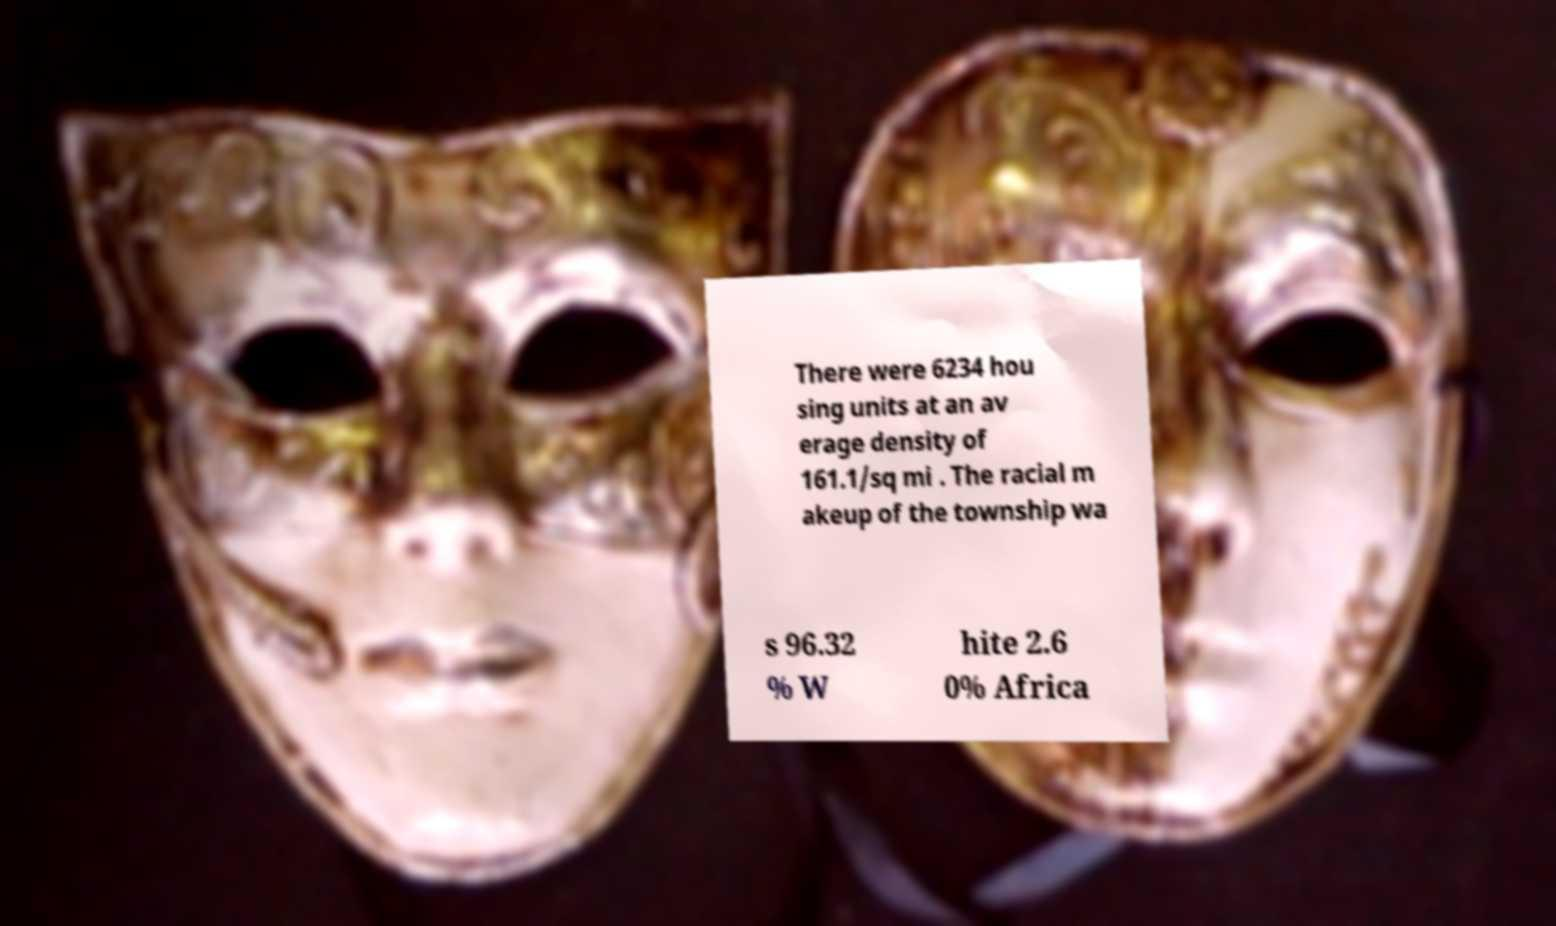For documentation purposes, I need the text within this image transcribed. Could you provide that? There were 6234 hou sing units at an av erage density of 161.1/sq mi . The racial m akeup of the township wa s 96.32 % W hite 2.6 0% Africa 